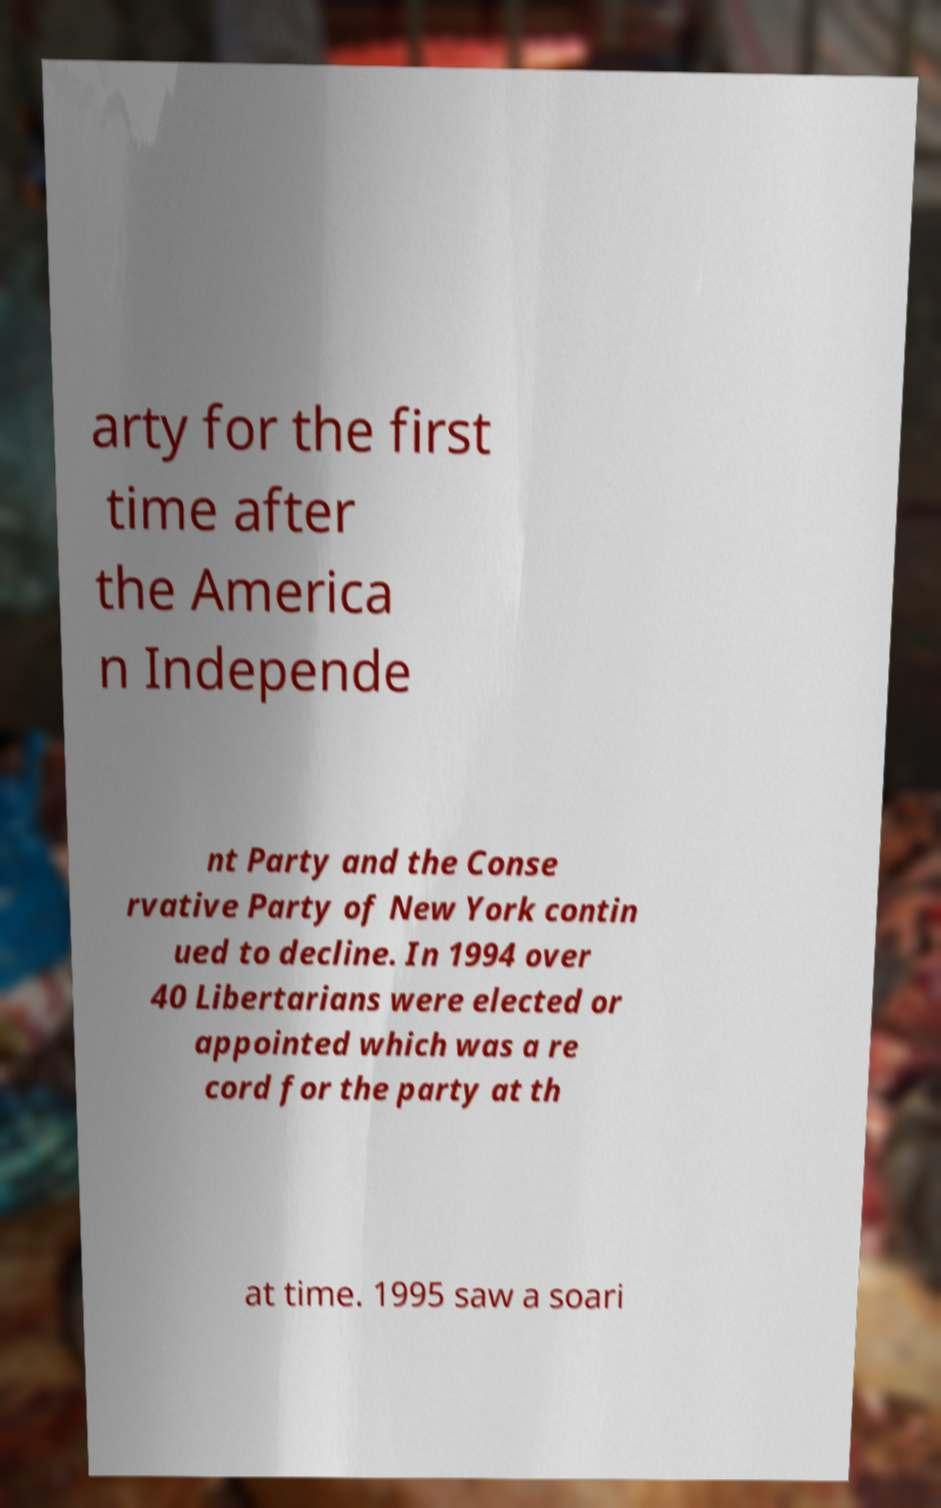Please identify and transcribe the text found in this image. arty for the first time after the America n Independe nt Party and the Conse rvative Party of New York contin ued to decline. In 1994 over 40 Libertarians were elected or appointed which was a re cord for the party at th at time. 1995 saw a soari 